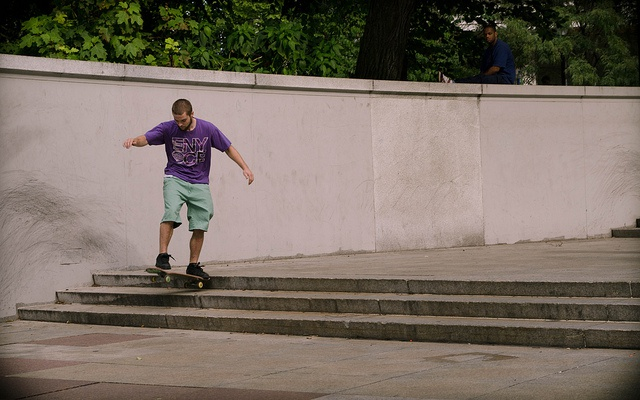Describe the objects in this image and their specific colors. I can see people in black, darkgray, purple, and gray tones, people in black, maroon, and darkgray tones, and skateboard in black and gray tones in this image. 